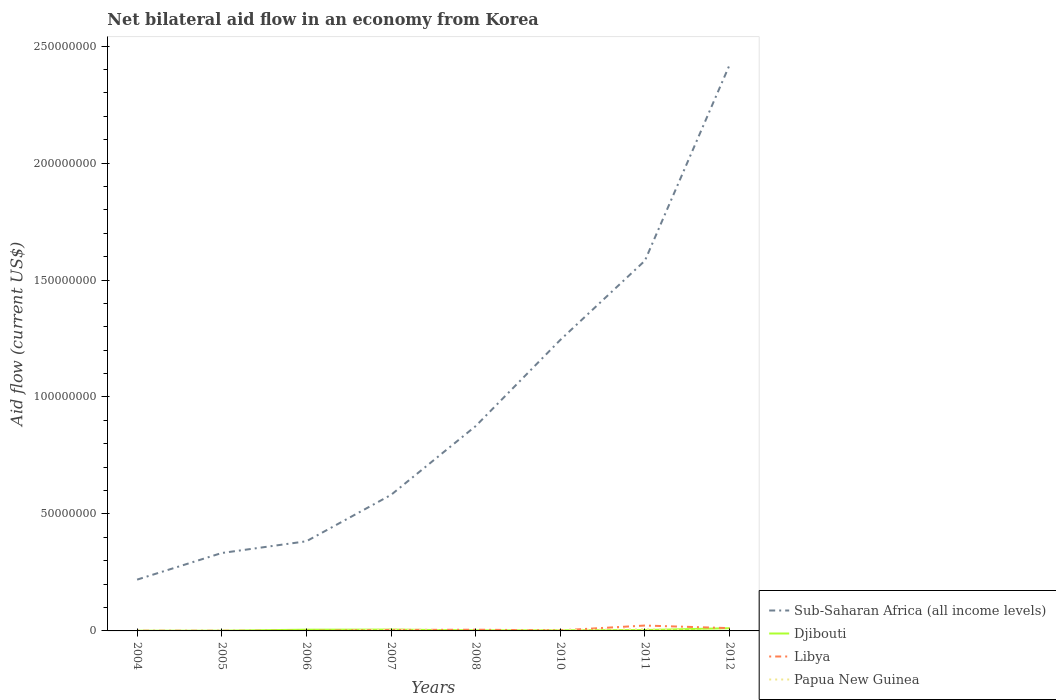Across all years, what is the maximum net bilateral aid flow in Libya?
Offer a terse response. 6.00e+04. What is the difference between the highest and the second highest net bilateral aid flow in Libya?
Provide a short and direct response. 2.24e+06. Is the net bilateral aid flow in Libya strictly greater than the net bilateral aid flow in Sub-Saharan Africa (all income levels) over the years?
Offer a terse response. Yes. How many lines are there?
Your response must be concise. 4. How many years are there in the graph?
Offer a very short reply. 8. Are the values on the major ticks of Y-axis written in scientific E-notation?
Ensure brevity in your answer.  No. How many legend labels are there?
Keep it short and to the point. 4. How are the legend labels stacked?
Make the answer very short. Vertical. What is the title of the graph?
Your answer should be very brief. Net bilateral aid flow in an economy from Korea. Does "Latin America(all income levels)" appear as one of the legend labels in the graph?
Your answer should be very brief. No. What is the label or title of the X-axis?
Make the answer very short. Years. What is the label or title of the Y-axis?
Offer a terse response. Aid flow (current US$). What is the Aid flow (current US$) of Sub-Saharan Africa (all income levels) in 2004?
Give a very brief answer. 2.19e+07. What is the Aid flow (current US$) of Libya in 2004?
Give a very brief answer. 9.00e+04. What is the Aid flow (current US$) in Papua New Guinea in 2004?
Make the answer very short. 0. What is the Aid flow (current US$) in Sub-Saharan Africa (all income levels) in 2005?
Ensure brevity in your answer.  3.33e+07. What is the Aid flow (current US$) of Djibouti in 2005?
Your answer should be compact. 1.00e+05. What is the Aid flow (current US$) of Papua New Guinea in 2005?
Keep it short and to the point. 0. What is the Aid flow (current US$) of Sub-Saharan Africa (all income levels) in 2006?
Your answer should be compact. 3.83e+07. What is the Aid flow (current US$) in Djibouti in 2006?
Provide a succinct answer. 5.30e+05. What is the Aid flow (current US$) in Libya in 2006?
Your answer should be compact. 6.00e+04. What is the Aid flow (current US$) of Sub-Saharan Africa (all income levels) in 2007?
Ensure brevity in your answer.  5.82e+07. What is the Aid flow (current US$) in Djibouti in 2007?
Give a very brief answer. 5.70e+05. What is the Aid flow (current US$) in Papua New Guinea in 2007?
Your response must be concise. 6.90e+05. What is the Aid flow (current US$) of Sub-Saharan Africa (all income levels) in 2008?
Keep it short and to the point. 8.76e+07. What is the Aid flow (current US$) in Libya in 2008?
Your response must be concise. 5.20e+05. What is the Aid flow (current US$) of Papua New Guinea in 2008?
Give a very brief answer. 0. What is the Aid flow (current US$) of Sub-Saharan Africa (all income levels) in 2010?
Offer a terse response. 1.24e+08. What is the Aid flow (current US$) in Djibouti in 2010?
Provide a succinct answer. 2.70e+05. What is the Aid flow (current US$) in Libya in 2010?
Offer a terse response. 2.40e+05. What is the Aid flow (current US$) in Papua New Guinea in 2010?
Give a very brief answer. 3.90e+05. What is the Aid flow (current US$) of Sub-Saharan Africa (all income levels) in 2011?
Give a very brief answer. 1.58e+08. What is the Aid flow (current US$) in Djibouti in 2011?
Keep it short and to the point. 3.90e+05. What is the Aid flow (current US$) in Libya in 2011?
Offer a terse response. 2.30e+06. What is the Aid flow (current US$) of Papua New Guinea in 2011?
Provide a short and direct response. 6.80e+05. What is the Aid flow (current US$) of Sub-Saharan Africa (all income levels) in 2012?
Provide a succinct answer. 2.42e+08. What is the Aid flow (current US$) in Djibouti in 2012?
Offer a very short reply. 1.16e+06. What is the Aid flow (current US$) in Libya in 2012?
Offer a terse response. 1.19e+06. What is the Aid flow (current US$) of Papua New Guinea in 2012?
Make the answer very short. 2.00e+04. Across all years, what is the maximum Aid flow (current US$) of Sub-Saharan Africa (all income levels)?
Your response must be concise. 2.42e+08. Across all years, what is the maximum Aid flow (current US$) of Djibouti?
Offer a very short reply. 1.16e+06. Across all years, what is the maximum Aid flow (current US$) in Libya?
Offer a terse response. 2.30e+06. Across all years, what is the maximum Aid flow (current US$) in Papua New Guinea?
Give a very brief answer. 6.90e+05. Across all years, what is the minimum Aid flow (current US$) in Sub-Saharan Africa (all income levels)?
Ensure brevity in your answer.  2.19e+07. Across all years, what is the minimum Aid flow (current US$) of Djibouti?
Ensure brevity in your answer.  9.00e+04. What is the total Aid flow (current US$) of Sub-Saharan Africa (all income levels) in the graph?
Your answer should be very brief. 7.64e+08. What is the total Aid flow (current US$) of Djibouti in the graph?
Offer a very short reply. 3.36e+06. What is the total Aid flow (current US$) in Libya in the graph?
Keep it short and to the point. 4.90e+06. What is the total Aid flow (current US$) in Papua New Guinea in the graph?
Your answer should be very brief. 1.78e+06. What is the difference between the Aid flow (current US$) in Sub-Saharan Africa (all income levels) in 2004 and that in 2005?
Your answer should be compact. -1.14e+07. What is the difference between the Aid flow (current US$) of Libya in 2004 and that in 2005?
Your response must be concise. 10000. What is the difference between the Aid flow (current US$) of Sub-Saharan Africa (all income levels) in 2004 and that in 2006?
Provide a short and direct response. -1.64e+07. What is the difference between the Aid flow (current US$) of Djibouti in 2004 and that in 2006?
Give a very brief answer. -4.40e+05. What is the difference between the Aid flow (current US$) in Libya in 2004 and that in 2006?
Your response must be concise. 3.00e+04. What is the difference between the Aid flow (current US$) of Sub-Saharan Africa (all income levels) in 2004 and that in 2007?
Your answer should be very brief. -3.62e+07. What is the difference between the Aid flow (current US$) of Djibouti in 2004 and that in 2007?
Provide a short and direct response. -4.80e+05. What is the difference between the Aid flow (current US$) of Libya in 2004 and that in 2007?
Your response must be concise. -3.30e+05. What is the difference between the Aid flow (current US$) in Sub-Saharan Africa (all income levels) in 2004 and that in 2008?
Make the answer very short. -6.56e+07. What is the difference between the Aid flow (current US$) of Libya in 2004 and that in 2008?
Give a very brief answer. -4.30e+05. What is the difference between the Aid flow (current US$) in Sub-Saharan Africa (all income levels) in 2004 and that in 2010?
Provide a succinct answer. -1.02e+08. What is the difference between the Aid flow (current US$) of Sub-Saharan Africa (all income levels) in 2004 and that in 2011?
Make the answer very short. -1.36e+08. What is the difference between the Aid flow (current US$) of Djibouti in 2004 and that in 2011?
Give a very brief answer. -3.00e+05. What is the difference between the Aid flow (current US$) of Libya in 2004 and that in 2011?
Your answer should be very brief. -2.21e+06. What is the difference between the Aid flow (current US$) of Sub-Saharan Africa (all income levels) in 2004 and that in 2012?
Offer a terse response. -2.20e+08. What is the difference between the Aid flow (current US$) in Djibouti in 2004 and that in 2012?
Keep it short and to the point. -1.07e+06. What is the difference between the Aid flow (current US$) in Libya in 2004 and that in 2012?
Your response must be concise. -1.10e+06. What is the difference between the Aid flow (current US$) of Sub-Saharan Africa (all income levels) in 2005 and that in 2006?
Offer a terse response. -5.01e+06. What is the difference between the Aid flow (current US$) of Djibouti in 2005 and that in 2006?
Offer a very short reply. -4.30e+05. What is the difference between the Aid flow (current US$) of Sub-Saharan Africa (all income levels) in 2005 and that in 2007?
Offer a very short reply. -2.48e+07. What is the difference between the Aid flow (current US$) of Djibouti in 2005 and that in 2007?
Your response must be concise. -4.70e+05. What is the difference between the Aid flow (current US$) of Sub-Saharan Africa (all income levels) in 2005 and that in 2008?
Keep it short and to the point. -5.42e+07. What is the difference between the Aid flow (current US$) in Libya in 2005 and that in 2008?
Your answer should be very brief. -4.40e+05. What is the difference between the Aid flow (current US$) in Sub-Saharan Africa (all income levels) in 2005 and that in 2010?
Your response must be concise. -9.11e+07. What is the difference between the Aid flow (current US$) of Sub-Saharan Africa (all income levels) in 2005 and that in 2011?
Your response must be concise. -1.25e+08. What is the difference between the Aid flow (current US$) of Djibouti in 2005 and that in 2011?
Ensure brevity in your answer.  -2.90e+05. What is the difference between the Aid flow (current US$) of Libya in 2005 and that in 2011?
Offer a terse response. -2.22e+06. What is the difference between the Aid flow (current US$) in Sub-Saharan Africa (all income levels) in 2005 and that in 2012?
Keep it short and to the point. -2.09e+08. What is the difference between the Aid flow (current US$) of Djibouti in 2005 and that in 2012?
Your answer should be compact. -1.06e+06. What is the difference between the Aid flow (current US$) of Libya in 2005 and that in 2012?
Your answer should be compact. -1.11e+06. What is the difference between the Aid flow (current US$) of Sub-Saharan Africa (all income levels) in 2006 and that in 2007?
Ensure brevity in your answer.  -1.98e+07. What is the difference between the Aid flow (current US$) of Libya in 2006 and that in 2007?
Give a very brief answer. -3.60e+05. What is the difference between the Aid flow (current US$) of Sub-Saharan Africa (all income levels) in 2006 and that in 2008?
Provide a succinct answer. -4.92e+07. What is the difference between the Aid flow (current US$) in Libya in 2006 and that in 2008?
Offer a very short reply. -4.60e+05. What is the difference between the Aid flow (current US$) in Sub-Saharan Africa (all income levels) in 2006 and that in 2010?
Provide a succinct answer. -8.61e+07. What is the difference between the Aid flow (current US$) of Djibouti in 2006 and that in 2010?
Offer a terse response. 2.60e+05. What is the difference between the Aid flow (current US$) in Sub-Saharan Africa (all income levels) in 2006 and that in 2011?
Provide a short and direct response. -1.20e+08. What is the difference between the Aid flow (current US$) of Libya in 2006 and that in 2011?
Provide a short and direct response. -2.24e+06. What is the difference between the Aid flow (current US$) in Sub-Saharan Africa (all income levels) in 2006 and that in 2012?
Your response must be concise. -2.04e+08. What is the difference between the Aid flow (current US$) of Djibouti in 2006 and that in 2012?
Give a very brief answer. -6.30e+05. What is the difference between the Aid flow (current US$) in Libya in 2006 and that in 2012?
Offer a terse response. -1.13e+06. What is the difference between the Aid flow (current US$) in Sub-Saharan Africa (all income levels) in 2007 and that in 2008?
Offer a very short reply. -2.94e+07. What is the difference between the Aid flow (current US$) in Libya in 2007 and that in 2008?
Your answer should be very brief. -1.00e+05. What is the difference between the Aid flow (current US$) in Sub-Saharan Africa (all income levels) in 2007 and that in 2010?
Offer a very short reply. -6.62e+07. What is the difference between the Aid flow (current US$) of Libya in 2007 and that in 2010?
Offer a very short reply. 1.80e+05. What is the difference between the Aid flow (current US$) of Papua New Guinea in 2007 and that in 2010?
Your response must be concise. 3.00e+05. What is the difference between the Aid flow (current US$) of Sub-Saharan Africa (all income levels) in 2007 and that in 2011?
Ensure brevity in your answer.  -1.00e+08. What is the difference between the Aid flow (current US$) in Djibouti in 2007 and that in 2011?
Offer a terse response. 1.80e+05. What is the difference between the Aid flow (current US$) in Libya in 2007 and that in 2011?
Make the answer very short. -1.88e+06. What is the difference between the Aid flow (current US$) of Sub-Saharan Africa (all income levels) in 2007 and that in 2012?
Your response must be concise. -1.84e+08. What is the difference between the Aid flow (current US$) in Djibouti in 2007 and that in 2012?
Make the answer very short. -5.90e+05. What is the difference between the Aid flow (current US$) in Libya in 2007 and that in 2012?
Give a very brief answer. -7.70e+05. What is the difference between the Aid flow (current US$) of Papua New Guinea in 2007 and that in 2012?
Provide a succinct answer. 6.70e+05. What is the difference between the Aid flow (current US$) in Sub-Saharan Africa (all income levels) in 2008 and that in 2010?
Your answer should be very brief. -3.68e+07. What is the difference between the Aid flow (current US$) in Djibouti in 2008 and that in 2010?
Offer a terse response. -2.00e+04. What is the difference between the Aid flow (current US$) in Sub-Saharan Africa (all income levels) in 2008 and that in 2011?
Give a very brief answer. -7.07e+07. What is the difference between the Aid flow (current US$) in Libya in 2008 and that in 2011?
Keep it short and to the point. -1.78e+06. What is the difference between the Aid flow (current US$) of Sub-Saharan Africa (all income levels) in 2008 and that in 2012?
Keep it short and to the point. -1.54e+08. What is the difference between the Aid flow (current US$) of Djibouti in 2008 and that in 2012?
Your answer should be compact. -9.10e+05. What is the difference between the Aid flow (current US$) of Libya in 2008 and that in 2012?
Give a very brief answer. -6.70e+05. What is the difference between the Aid flow (current US$) in Sub-Saharan Africa (all income levels) in 2010 and that in 2011?
Offer a terse response. -3.39e+07. What is the difference between the Aid flow (current US$) of Libya in 2010 and that in 2011?
Offer a terse response. -2.06e+06. What is the difference between the Aid flow (current US$) in Papua New Guinea in 2010 and that in 2011?
Your answer should be compact. -2.90e+05. What is the difference between the Aid flow (current US$) in Sub-Saharan Africa (all income levels) in 2010 and that in 2012?
Offer a terse response. -1.18e+08. What is the difference between the Aid flow (current US$) in Djibouti in 2010 and that in 2012?
Provide a succinct answer. -8.90e+05. What is the difference between the Aid flow (current US$) of Libya in 2010 and that in 2012?
Provide a short and direct response. -9.50e+05. What is the difference between the Aid flow (current US$) in Papua New Guinea in 2010 and that in 2012?
Provide a short and direct response. 3.70e+05. What is the difference between the Aid flow (current US$) in Sub-Saharan Africa (all income levels) in 2011 and that in 2012?
Offer a terse response. -8.37e+07. What is the difference between the Aid flow (current US$) of Djibouti in 2011 and that in 2012?
Offer a terse response. -7.70e+05. What is the difference between the Aid flow (current US$) in Libya in 2011 and that in 2012?
Provide a succinct answer. 1.11e+06. What is the difference between the Aid flow (current US$) in Sub-Saharan Africa (all income levels) in 2004 and the Aid flow (current US$) in Djibouti in 2005?
Your answer should be very brief. 2.18e+07. What is the difference between the Aid flow (current US$) in Sub-Saharan Africa (all income levels) in 2004 and the Aid flow (current US$) in Libya in 2005?
Your answer should be compact. 2.18e+07. What is the difference between the Aid flow (current US$) of Djibouti in 2004 and the Aid flow (current US$) of Libya in 2005?
Ensure brevity in your answer.  10000. What is the difference between the Aid flow (current US$) in Sub-Saharan Africa (all income levels) in 2004 and the Aid flow (current US$) in Djibouti in 2006?
Your answer should be compact. 2.14e+07. What is the difference between the Aid flow (current US$) in Sub-Saharan Africa (all income levels) in 2004 and the Aid flow (current US$) in Libya in 2006?
Offer a very short reply. 2.19e+07. What is the difference between the Aid flow (current US$) in Djibouti in 2004 and the Aid flow (current US$) in Libya in 2006?
Your response must be concise. 3.00e+04. What is the difference between the Aid flow (current US$) in Sub-Saharan Africa (all income levels) in 2004 and the Aid flow (current US$) in Djibouti in 2007?
Ensure brevity in your answer.  2.14e+07. What is the difference between the Aid flow (current US$) in Sub-Saharan Africa (all income levels) in 2004 and the Aid flow (current US$) in Libya in 2007?
Offer a very short reply. 2.15e+07. What is the difference between the Aid flow (current US$) of Sub-Saharan Africa (all income levels) in 2004 and the Aid flow (current US$) of Papua New Guinea in 2007?
Give a very brief answer. 2.12e+07. What is the difference between the Aid flow (current US$) of Djibouti in 2004 and the Aid flow (current US$) of Libya in 2007?
Your answer should be compact. -3.30e+05. What is the difference between the Aid flow (current US$) in Djibouti in 2004 and the Aid flow (current US$) in Papua New Guinea in 2007?
Make the answer very short. -6.00e+05. What is the difference between the Aid flow (current US$) of Libya in 2004 and the Aid flow (current US$) of Papua New Guinea in 2007?
Your answer should be compact. -6.00e+05. What is the difference between the Aid flow (current US$) in Sub-Saharan Africa (all income levels) in 2004 and the Aid flow (current US$) in Djibouti in 2008?
Make the answer very short. 2.17e+07. What is the difference between the Aid flow (current US$) in Sub-Saharan Africa (all income levels) in 2004 and the Aid flow (current US$) in Libya in 2008?
Provide a short and direct response. 2.14e+07. What is the difference between the Aid flow (current US$) in Djibouti in 2004 and the Aid flow (current US$) in Libya in 2008?
Your answer should be compact. -4.30e+05. What is the difference between the Aid flow (current US$) in Sub-Saharan Africa (all income levels) in 2004 and the Aid flow (current US$) in Djibouti in 2010?
Provide a succinct answer. 2.17e+07. What is the difference between the Aid flow (current US$) of Sub-Saharan Africa (all income levels) in 2004 and the Aid flow (current US$) of Libya in 2010?
Offer a very short reply. 2.17e+07. What is the difference between the Aid flow (current US$) of Sub-Saharan Africa (all income levels) in 2004 and the Aid flow (current US$) of Papua New Guinea in 2010?
Give a very brief answer. 2.15e+07. What is the difference between the Aid flow (current US$) of Djibouti in 2004 and the Aid flow (current US$) of Papua New Guinea in 2010?
Offer a terse response. -3.00e+05. What is the difference between the Aid flow (current US$) of Libya in 2004 and the Aid flow (current US$) of Papua New Guinea in 2010?
Offer a terse response. -3.00e+05. What is the difference between the Aid flow (current US$) of Sub-Saharan Africa (all income levels) in 2004 and the Aid flow (current US$) of Djibouti in 2011?
Give a very brief answer. 2.15e+07. What is the difference between the Aid flow (current US$) in Sub-Saharan Africa (all income levels) in 2004 and the Aid flow (current US$) in Libya in 2011?
Keep it short and to the point. 1.96e+07. What is the difference between the Aid flow (current US$) in Sub-Saharan Africa (all income levels) in 2004 and the Aid flow (current US$) in Papua New Guinea in 2011?
Provide a short and direct response. 2.12e+07. What is the difference between the Aid flow (current US$) of Djibouti in 2004 and the Aid flow (current US$) of Libya in 2011?
Give a very brief answer. -2.21e+06. What is the difference between the Aid flow (current US$) in Djibouti in 2004 and the Aid flow (current US$) in Papua New Guinea in 2011?
Give a very brief answer. -5.90e+05. What is the difference between the Aid flow (current US$) in Libya in 2004 and the Aid flow (current US$) in Papua New Guinea in 2011?
Provide a short and direct response. -5.90e+05. What is the difference between the Aid flow (current US$) of Sub-Saharan Africa (all income levels) in 2004 and the Aid flow (current US$) of Djibouti in 2012?
Offer a very short reply. 2.08e+07. What is the difference between the Aid flow (current US$) of Sub-Saharan Africa (all income levels) in 2004 and the Aid flow (current US$) of Libya in 2012?
Offer a very short reply. 2.07e+07. What is the difference between the Aid flow (current US$) of Sub-Saharan Africa (all income levels) in 2004 and the Aid flow (current US$) of Papua New Guinea in 2012?
Make the answer very short. 2.19e+07. What is the difference between the Aid flow (current US$) in Djibouti in 2004 and the Aid flow (current US$) in Libya in 2012?
Offer a terse response. -1.10e+06. What is the difference between the Aid flow (current US$) in Djibouti in 2004 and the Aid flow (current US$) in Papua New Guinea in 2012?
Your response must be concise. 7.00e+04. What is the difference between the Aid flow (current US$) of Sub-Saharan Africa (all income levels) in 2005 and the Aid flow (current US$) of Djibouti in 2006?
Your answer should be very brief. 3.28e+07. What is the difference between the Aid flow (current US$) of Sub-Saharan Africa (all income levels) in 2005 and the Aid flow (current US$) of Libya in 2006?
Your response must be concise. 3.32e+07. What is the difference between the Aid flow (current US$) in Sub-Saharan Africa (all income levels) in 2005 and the Aid flow (current US$) in Djibouti in 2007?
Keep it short and to the point. 3.27e+07. What is the difference between the Aid flow (current US$) of Sub-Saharan Africa (all income levels) in 2005 and the Aid flow (current US$) of Libya in 2007?
Ensure brevity in your answer.  3.29e+07. What is the difference between the Aid flow (current US$) of Sub-Saharan Africa (all income levels) in 2005 and the Aid flow (current US$) of Papua New Guinea in 2007?
Your answer should be very brief. 3.26e+07. What is the difference between the Aid flow (current US$) of Djibouti in 2005 and the Aid flow (current US$) of Libya in 2007?
Keep it short and to the point. -3.20e+05. What is the difference between the Aid flow (current US$) of Djibouti in 2005 and the Aid flow (current US$) of Papua New Guinea in 2007?
Provide a succinct answer. -5.90e+05. What is the difference between the Aid flow (current US$) of Libya in 2005 and the Aid flow (current US$) of Papua New Guinea in 2007?
Provide a short and direct response. -6.10e+05. What is the difference between the Aid flow (current US$) in Sub-Saharan Africa (all income levels) in 2005 and the Aid flow (current US$) in Djibouti in 2008?
Make the answer very short. 3.31e+07. What is the difference between the Aid flow (current US$) of Sub-Saharan Africa (all income levels) in 2005 and the Aid flow (current US$) of Libya in 2008?
Ensure brevity in your answer.  3.28e+07. What is the difference between the Aid flow (current US$) of Djibouti in 2005 and the Aid flow (current US$) of Libya in 2008?
Provide a short and direct response. -4.20e+05. What is the difference between the Aid flow (current US$) in Sub-Saharan Africa (all income levels) in 2005 and the Aid flow (current US$) in Djibouti in 2010?
Your answer should be very brief. 3.30e+07. What is the difference between the Aid flow (current US$) in Sub-Saharan Africa (all income levels) in 2005 and the Aid flow (current US$) in Libya in 2010?
Keep it short and to the point. 3.31e+07. What is the difference between the Aid flow (current US$) of Sub-Saharan Africa (all income levels) in 2005 and the Aid flow (current US$) of Papua New Guinea in 2010?
Make the answer very short. 3.29e+07. What is the difference between the Aid flow (current US$) of Libya in 2005 and the Aid flow (current US$) of Papua New Guinea in 2010?
Ensure brevity in your answer.  -3.10e+05. What is the difference between the Aid flow (current US$) of Sub-Saharan Africa (all income levels) in 2005 and the Aid flow (current US$) of Djibouti in 2011?
Provide a short and direct response. 3.29e+07. What is the difference between the Aid flow (current US$) in Sub-Saharan Africa (all income levels) in 2005 and the Aid flow (current US$) in Libya in 2011?
Give a very brief answer. 3.10e+07. What is the difference between the Aid flow (current US$) in Sub-Saharan Africa (all income levels) in 2005 and the Aid flow (current US$) in Papua New Guinea in 2011?
Offer a terse response. 3.26e+07. What is the difference between the Aid flow (current US$) in Djibouti in 2005 and the Aid flow (current US$) in Libya in 2011?
Give a very brief answer. -2.20e+06. What is the difference between the Aid flow (current US$) in Djibouti in 2005 and the Aid flow (current US$) in Papua New Guinea in 2011?
Provide a succinct answer. -5.80e+05. What is the difference between the Aid flow (current US$) of Libya in 2005 and the Aid flow (current US$) of Papua New Guinea in 2011?
Offer a very short reply. -6.00e+05. What is the difference between the Aid flow (current US$) in Sub-Saharan Africa (all income levels) in 2005 and the Aid flow (current US$) in Djibouti in 2012?
Provide a succinct answer. 3.22e+07. What is the difference between the Aid flow (current US$) in Sub-Saharan Africa (all income levels) in 2005 and the Aid flow (current US$) in Libya in 2012?
Keep it short and to the point. 3.21e+07. What is the difference between the Aid flow (current US$) in Sub-Saharan Africa (all income levels) in 2005 and the Aid flow (current US$) in Papua New Guinea in 2012?
Offer a very short reply. 3.33e+07. What is the difference between the Aid flow (current US$) of Djibouti in 2005 and the Aid flow (current US$) of Libya in 2012?
Offer a very short reply. -1.09e+06. What is the difference between the Aid flow (current US$) in Sub-Saharan Africa (all income levels) in 2006 and the Aid flow (current US$) in Djibouti in 2007?
Ensure brevity in your answer.  3.78e+07. What is the difference between the Aid flow (current US$) in Sub-Saharan Africa (all income levels) in 2006 and the Aid flow (current US$) in Libya in 2007?
Make the answer very short. 3.79e+07. What is the difference between the Aid flow (current US$) in Sub-Saharan Africa (all income levels) in 2006 and the Aid flow (current US$) in Papua New Guinea in 2007?
Make the answer very short. 3.76e+07. What is the difference between the Aid flow (current US$) in Djibouti in 2006 and the Aid flow (current US$) in Libya in 2007?
Your response must be concise. 1.10e+05. What is the difference between the Aid flow (current US$) in Djibouti in 2006 and the Aid flow (current US$) in Papua New Guinea in 2007?
Your answer should be compact. -1.60e+05. What is the difference between the Aid flow (current US$) of Libya in 2006 and the Aid flow (current US$) of Papua New Guinea in 2007?
Offer a very short reply. -6.30e+05. What is the difference between the Aid flow (current US$) in Sub-Saharan Africa (all income levels) in 2006 and the Aid flow (current US$) in Djibouti in 2008?
Offer a terse response. 3.81e+07. What is the difference between the Aid flow (current US$) in Sub-Saharan Africa (all income levels) in 2006 and the Aid flow (current US$) in Libya in 2008?
Provide a short and direct response. 3.78e+07. What is the difference between the Aid flow (current US$) in Djibouti in 2006 and the Aid flow (current US$) in Libya in 2008?
Your answer should be very brief. 10000. What is the difference between the Aid flow (current US$) of Sub-Saharan Africa (all income levels) in 2006 and the Aid flow (current US$) of Djibouti in 2010?
Provide a short and direct response. 3.80e+07. What is the difference between the Aid flow (current US$) in Sub-Saharan Africa (all income levels) in 2006 and the Aid flow (current US$) in Libya in 2010?
Your answer should be compact. 3.81e+07. What is the difference between the Aid flow (current US$) in Sub-Saharan Africa (all income levels) in 2006 and the Aid flow (current US$) in Papua New Guinea in 2010?
Offer a very short reply. 3.79e+07. What is the difference between the Aid flow (current US$) of Djibouti in 2006 and the Aid flow (current US$) of Papua New Guinea in 2010?
Your answer should be compact. 1.40e+05. What is the difference between the Aid flow (current US$) of Libya in 2006 and the Aid flow (current US$) of Papua New Guinea in 2010?
Ensure brevity in your answer.  -3.30e+05. What is the difference between the Aid flow (current US$) in Sub-Saharan Africa (all income levels) in 2006 and the Aid flow (current US$) in Djibouti in 2011?
Offer a terse response. 3.79e+07. What is the difference between the Aid flow (current US$) of Sub-Saharan Africa (all income levels) in 2006 and the Aid flow (current US$) of Libya in 2011?
Offer a very short reply. 3.60e+07. What is the difference between the Aid flow (current US$) of Sub-Saharan Africa (all income levels) in 2006 and the Aid flow (current US$) of Papua New Guinea in 2011?
Your answer should be very brief. 3.76e+07. What is the difference between the Aid flow (current US$) of Djibouti in 2006 and the Aid flow (current US$) of Libya in 2011?
Offer a terse response. -1.77e+06. What is the difference between the Aid flow (current US$) of Djibouti in 2006 and the Aid flow (current US$) of Papua New Guinea in 2011?
Keep it short and to the point. -1.50e+05. What is the difference between the Aid flow (current US$) of Libya in 2006 and the Aid flow (current US$) of Papua New Guinea in 2011?
Give a very brief answer. -6.20e+05. What is the difference between the Aid flow (current US$) of Sub-Saharan Africa (all income levels) in 2006 and the Aid flow (current US$) of Djibouti in 2012?
Ensure brevity in your answer.  3.72e+07. What is the difference between the Aid flow (current US$) in Sub-Saharan Africa (all income levels) in 2006 and the Aid flow (current US$) in Libya in 2012?
Your response must be concise. 3.71e+07. What is the difference between the Aid flow (current US$) of Sub-Saharan Africa (all income levels) in 2006 and the Aid flow (current US$) of Papua New Guinea in 2012?
Keep it short and to the point. 3.83e+07. What is the difference between the Aid flow (current US$) of Djibouti in 2006 and the Aid flow (current US$) of Libya in 2012?
Offer a terse response. -6.60e+05. What is the difference between the Aid flow (current US$) in Djibouti in 2006 and the Aid flow (current US$) in Papua New Guinea in 2012?
Your answer should be compact. 5.10e+05. What is the difference between the Aid flow (current US$) of Sub-Saharan Africa (all income levels) in 2007 and the Aid flow (current US$) of Djibouti in 2008?
Offer a terse response. 5.79e+07. What is the difference between the Aid flow (current US$) in Sub-Saharan Africa (all income levels) in 2007 and the Aid flow (current US$) in Libya in 2008?
Your response must be concise. 5.76e+07. What is the difference between the Aid flow (current US$) in Djibouti in 2007 and the Aid flow (current US$) in Libya in 2008?
Provide a short and direct response. 5.00e+04. What is the difference between the Aid flow (current US$) in Sub-Saharan Africa (all income levels) in 2007 and the Aid flow (current US$) in Djibouti in 2010?
Offer a terse response. 5.79e+07. What is the difference between the Aid flow (current US$) in Sub-Saharan Africa (all income levels) in 2007 and the Aid flow (current US$) in Libya in 2010?
Make the answer very short. 5.79e+07. What is the difference between the Aid flow (current US$) of Sub-Saharan Africa (all income levels) in 2007 and the Aid flow (current US$) of Papua New Guinea in 2010?
Offer a very short reply. 5.78e+07. What is the difference between the Aid flow (current US$) of Djibouti in 2007 and the Aid flow (current US$) of Libya in 2010?
Give a very brief answer. 3.30e+05. What is the difference between the Aid flow (current US$) of Djibouti in 2007 and the Aid flow (current US$) of Papua New Guinea in 2010?
Offer a very short reply. 1.80e+05. What is the difference between the Aid flow (current US$) in Sub-Saharan Africa (all income levels) in 2007 and the Aid flow (current US$) in Djibouti in 2011?
Your answer should be very brief. 5.78e+07. What is the difference between the Aid flow (current US$) of Sub-Saharan Africa (all income levels) in 2007 and the Aid flow (current US$) of Libya in 2011?
Provide a short and direct response. 5.58e+07. What is the difference between the Aid flow (current US$) of Sub-Saharan Africa (all income levels) in 2007 and the Aid flow (current US$) of Papua New Guinea in 2011?
Provide a short and direct response. 5.75e+07. What is the difference between the Aid flow (current US$) in Djibouti in 2007 and the Aid flow (current US$) in Libya in 2011?
Your answer should be very brief. -1.73e+06. What is the difference between the Aid flow (current US$) of Sub-Saharan Africa (all income levels) in 2007 and the Aid flow (current US$) of Djibouti in 2012?
Ensure brevity in your answer.  5.70e+07. What is the difference between the Aid flow (current US$) of Sub-Saharan Africa (all income levels) in 2007 and the Aid flow (current US$) of Libya in 2012?
Make the answer very short. 5.70e+07. What is the difference between the Aid flow (current US$) in Sub-Saharan Africa (all income levels) in 2007 and the Aid flow (current US$) in Papua New Guinea in 2012?
Your answer should be very brief. 5.81e+07. What is the difference between the Aid flow (current US$) of Djibouti in 2007 and the Aid flow (current US$) of Libya in 2012?
Provide a succinct answer. -6.20e+05. What is the difference between the Aid flow (current US$) of Djibouti in 2007 and the Aid flow (current US$) of Papua New Guinea in 2012?
Your answer should be compact. 5.50e+05. What is the difference between the Aid flow (current US$) in Sub-Saharan Africa (all income levels) in 2008 and the Aid flow (current US$) in Djibouti in 2010?
Your response must be concise. 8.73e+07. What is the difference between the Aid flow (current US$) of Sub-Saharan Africa (all income levels) in 2008 and the Aid flow (current US$) of Libya in 2010?
Keep it short and to the point. 8.73e+07. What is the difference between the Aid flow (current US$) in Sub-Saharan Africa (all income levels) in 2008 and the Aid flow (current US$) in Papua New Guinea in 2010?
Offer a terse response. 8.72e+07. What is the difference between the Aid flow (current US$) in Djibouti in 2008 and the Aid flow (current US$) in Libya in 2010?
Your answer should be very brief. 10000. What is the difference between the Aid flow (current US$) of Sub-Saharan Africa (all income levels) in 2008 and the Aid flow (current US$) of Djibouti in 2011?
Make the answer very short. 8.72e+07. What is the difference between the Aid flow (current US$) in Sub-Saharan Africa (all income levels) in 2008 and the Aid flow (current US$) in Libya in 2011?
Your answer should be compact. 8.52e+07. What is the difference between the Aid flow (current US$) of Sub-Saharan Africa (all income levels) in 2008 and the Aid flow (current US$) of Papua New Guinea in 2011?
Provide a short and direct response. 8.69e+07. What is the difference between the Aid flow (current US$) in Djibouti in 2008 and the Aid flow (current US$) in Libya in 2011?
Your answer should be very brief. -2.05e+06. What is the difference between the Aid flow (current US$) of Djibouti in 2008 and the Aid flow (current US$) of Papua New Guinea in 2011?
Your answer should be very brief. -4.30e+05. What is the difference between the Aid flow (current US$) in Sub-Saharan Africa (all income levels) in 2008 and the Aid flow (current US$) in Djibouti in 2012?
Provide a succinct answer. 8.64e+07. What is the difference between the Aid flow (current US$) of Sub-Saharan Africa (all income levels) in 2008 and the Aid flow (current US$) of Libya in 2012?
Give a very brief answer. 8.64e+07. What is the difference between the Aid flow (current US$) in Sub-Saharan Africa (all income levels) in 2008 and the Aid flow (current US$) in Papua New Guinea in 2012?
Provide a succinct answer. 8.75e+07. What is the difference between the Aid flow (current US$) of Djibouti in 2008 and the Aid flow (current US$) of Libya in 2012?
Ensure brevity in your answer.  -9.40e+05. What is the difference between the Aid flow (current US$) in Djibouti in 2008 and the Aid flow (current US$) in Papua New Guinea in 2012?
Ensure brevity in your answer.  2.30e+05. What is the difference between the Aid flow (current US$) in Libya in 2008 and the Aid flow (current US$) in Papua New Guinea in 2012?
Offer a very short reply. 5.00e+05. What is the difference between the Aid flow (current US$) of Sub-Saharan Africa (all income levels) in 2010 and the Aid flow (current US$) of Djibouti in 2011?
Provide a succinct answer. 1.24e+08. What is the difference between the Aid flow (current US$) of Sub-Saharan Africa (all income levels) in 2010 and the Aid flow (current US$) of Libya in 2011?
Make the answer very short. 1.22e+08. What is the difference between the Aid flow (current US$) in Sub-Saharan Africa (all income levels) in 2010 and the Aid flow (current US$) in Papua New Guinea in 2011?
Give a very brief answer. 1.24e+08. What is the difference between the Aid flow (current US$) of Djibouti in 2010 and the Aid flow (current US$) of Libya in 2011?
Keep it short and to the point. -2.03e+06. What is the difference between the Aid flow (current US$) in Djibouti in 2010 and the Aid flow (current US$) in Papua New Guinea in 2011?
Provide a short and direct response. -4.10e+05. What is the difference between the Aid flow (current US$) in Libya in 2010 and the Aid flow (current US$) in Papua New Guinea in 2011?
Your answer should be compact. -4.40e+05. What is the difference between the Aid flow (current US$) of Sub-Saharan Africa (all income levels) in 2010 and the Aid flow (current US$) of Djibouti in 2012?
Keep it short and to the point. 1.23e+08. What is the difference between the Aid flow (current US$) of Sub-Saharan Africa (all income levels) in 2010 and the Aid flow (current US$) of Libya in 2012?
Keep it short and to the point. 1.23e+08. What is the difference between the Aid flow (current US$) of Sub-Saharan Africa (all income levels) in 2010 and the Aid flow (current US$) of Papua New Guinea in 2012?
Give a very brief answer. 1.24e+08. What is the difference between the Aid flow (current US$) in Djibouti in 2010 and the Aid flow (current US$) in Libya in 2012?
Offer a very short reply. -9.20e+05. What is the difference between the Aid flow (current US$) of Sub-Saharan Africa (all income levels) in 2011 and the Aid flow (current US$) of Djibouti in 2012?
Give a very brief answer. 1.57e+08. What is the difference between the Aid flow (current US$) of Sub-Saharan Africa (all income levels) in 2011 and the Aid flow (current US$) of Libya in 2012?
Offer a terse response. 1.57e+08. What is the difference between the Aid flow (current US$) of Sub-Saharan Africa (all income levels) in 2011 and the Aid flow (current US$) of Papua New Guinea in 2012?
Make the answer very short. 1.58e+08. What is the difference between the Aid flow (current US$) in Djibouti in 2011 and the Aid flow (current US$) in Libya in 2012?
Provide a succinct answer. -8.00e+05. What is the difference between the Aid flow (current US$) of Djibouti in 2011 and the Aid flow (current US$) of Papua New Guinea in 2012?
Offer a terse response. 3.70e+05. What is the difference between the Aid flow (current US$) in Libya in 2011 and the Aid flow (current US$) in Papua New Guinea in 2012?
Your answer should be very brief. 2.28e+06. What is the average Aid flow (current US$) in Sub-Saharan Africa (all income levels) per year?
Provide a succinct answer. 9.55e+07. What is the average Aid flow (current US$) in Libya per year?
Keep it short and to the point. 6.12e+05. What is the average Aid flow (current US$) in Papua New Guinea per year?
Offer a terse response. 2.22e+05. In the year 2004, what is the difference between the Aid flow (current US$) of Sub-Saharan Africa (all income levels) and Aid flow (current US$) of Djibouti?
Keep it short and to the point. 2.18e+07. In the year 2004, what is the difference between the Aid flow (current US$) in Sub-Saharan Africa (all income levels) and Aid flow (current US$) in Libya?
Offer a terse response. 2.18e+07. In the year 2004, what is the difference between the Aid flow (current US$) in Djibouti and Aid flow (current US$) in Libya?
Your answer should be very brief. 0. In the year 2005, what is the difference between the Aid flow (current US$) of Sub-Saharan Africa (all income levels) and Aid flow (current US$) of Djibouti?
Your answer should be very brief. 3.32e+07. In the year 2005, what is the difference between the Aid flow (current US$) of Sub-Saharan Africa (all income levels) and Aid flow (current US$) of Libya?
Give a very brief answer. 3.32e+07. In the year 2005, what is the difference between the Aid flow (current US$) of Djibouti and Aid flow (current US$) of Libya?
Make the answer very short. 2.00e+04. In the year 2006, what is the difference between the Aid flow (current US$) of Sub-Saharan Africa (all income levels) and Aid flow (current US$) of Djibouti?
Keep it short and to the point. 3.78e+07. In the year 2006, what is the difference between the Aid flow (current US$) of Sub-Saharan Africa (all income levels) and Aid flow (current US$) of Libya?
Ensure brevity in your answer.  3.83e+07. In the year 2006, what is the difference between the Aid flow (current US$) of Djibouti and Aid flow (current US$) of Libya?
Make the answer very short. 4.70e+05. In the year 2007, what is the difference between the Aid flow (current US$) in Sub-Saharan Africa (all income levels) and Aid flow (current US$) in Djibouti?
Make the answer very short. 5.76e+07. In the year 2007, what is the difference between the Aid flow (current US$) of Sub-Saharan Africa (all income levels) and Aid flow (current US$) of Libya?
Ensure brevity in your answer.  5.77e+07. In the year 2007, what is the difference between the Aid flow (current US$) of Sub-Saharan Africa (all income levels) and Aid flow (current US$) of Papua New Guinea?
Ensure brevity in your answer.  5.75e+07. In the year 2007, what is the difference between the Aid flow (current US$) in Djibouti and Aid flow (current US$) in Papua New Guinea?
Offer a very short reply. -1.20e+05. In the year 2007, what is the difference between the Aid flow (current US$) of Libya and Aid flow (current US$) of Papua New Guinea?
Offer a terse response. -2.70e+05. In the year 2008, what is the difference between the Aid flow (current US$) in Sub-Saharan Africa (all income levels) and Aid flow (current US$) in Djibouti?
Offer a terse response. 8.73e+07. In the year 2008, what is the difference between the Aid flow (current US$) of Sub-Saharan Africa (all income levels) and Aid flow (current US$) of Libya?
Ensure brevity in your answer.  8.70e+07. In the year 2008, what is the difference between the Aid flow (current US$) of Djibouti and Aid flow (current US$) of Libya?
Keep it short and to the point. -2.70e+05. In the year 2010, what is the difference between the Aid flow (current US$) in Sub-Saharan Africa (all income levels) and Aid flow (current US$) in Djibouti?
Offer a very short reply. 1.24e+08. In the year 2010, what is the difference between the Aid flow (current US$) of Sub-Saharan Africa (all income levels) and Aid flow (current US$) of Libya?
Your answer should be very brief. 1.24e+08. In the year 2010, what is the difference between the Aid flow (current US$) in Sub-Saharan Africa (all income levels) and Aid flow (current US$) in Papua New Guinea?
Your response must be concise. 1.24e+08. In the year 2010, what is the difference between the Aid flow (current US$) of Djibouti and Aid flow (current US$) of Papua New Guinea?
Ensure brevity in your answer.  -1.20e+05. In the year 2011, what is the difference between the Aid flow (current US$) in Sub-Saharan Africa (all income levels) and Aid flow (current US$) in Djibouti?
Keep it short and to the point. 1.58e+08. In the year 2011, what is the difference between the Aid flow (current US$) of Sub-Saharan Africa (all income levels) and Aid flow (current US$) of Libya?
Ensure brevity in your answer.  1.56e+08. In the year 2011, what is the difference between the Aid flow (current US$) in Sub-Saharan Africa (all income levels) and Aid flow (current US$) in Papua New Guinea?
Your answer should be compact. 1.58e+08. In the year 2011, what is the difference between the Aid flow (current US$) in Djibouti and Aid flow (current US$) in Libya?
Give a very brief answer. -1.91e+06. In the year 2011, what is the difference between the Aid flow (current US$) of Djibouti and Aid flow (current US$) of Papua New Guinea?
Ensure brevity in your answer.  -2.90e+05. In the year 2011, what is the difference between the Aid flow (current US$) in Libya and Aid flow (current US$) in Papua New Guinea?
Provide a short and direct response. 1.62e+06. In the year 2012, what is the difference between the Aid flow (current US$) of Sub-Saharan Africa (all income levels) and Aid flow (current US$) of Djibouti?
Provide a succinct answer. 2.41e+08. In the year 2012, what is the difference between the Aid flow (current US$) in Sub-Saharan Africa (all income levels) and Aid flow (current US$) in Libya?
Offer a terse response. 2.41e+08. In the year 2012, what is the difference between the Aid flow (current US$) in Sub-Saharan Africa (all income levels) and Aid flow (current US$) in Papua New Guinea?
Provide a succinct answer. 2.42e+08. In the year 2012, what is the difference between the Aid flow (current US$) in Djibouti and Aid flow (current US$) in Papua New Guinea?
Give a very brief answer. 1.14e+06. In the year 2012, what is the difference between the Aid flow (current US$) of Libya and Aid flow (current US$) of Papua New Guinea?
Offer a terse response. 1.17e+06. What is the ratio of the Aid flow (current US$) of Sub-Saharan Africa (all income levels) in 2004 to that in 2005?
Offer a terse response. 0.66. What is the ratio of the Aid flow (current US$) in Djibouti in 2004 to that in 2005?
Provide a short and direct response. 0.9. What is the ratio of the Aid flow (current US$) in Libya in 2004 to that in 2005?
Give a very brief answer. 1.12. What is the ratio of the Aid flow (current US$) of Sub-Saharan Africa (all income levels) in 2004 to that in 2006?
Your answer should be compact. 0.57. What is the ratio of the Aid flow (current US$) in Djibouti in 2004 to that in 2006?
Provide a short and direct response. 0.17. What is the ratio of the Aid flow (current US$) in Libya in 2004 to that in 2006?
Your response must be concise. 1.5. What is the ratio of the Aid flow (current US$) in Sub-Saharan Africa (all income levels) in 2004 to that in 2007?
Your answer should be compact. 0.38. What is the ratio of the Aid flow (current US$) in Djibouti in 2004 to that in 2007?
Make the answer very short. 0.16. What is the ratio of the Aid flow (current US$) of Libya in 2004 to that in 2007?
Make the answer very short. 0.21. What is the ratio of the Aid flow (current US$) of Sub-Saharan Africa (all income levels) in 2004 to that in 2008?
Provide a short and direct response. 0.25. What is the ratio of the Aid flow (current US$) of Djibouti in 2004 to that in 2008?
Provide a succinct answer. 0.36. What is the ratio of the Aid flow (current US$) in Libya in 2004 to that in 2008?
Give a very brief answer. 0.17. What is the ratio of the Aid flow (current US$) in Sub-Saharan Africa (all income levels) in 2004 to that in 2010?
Ensure brevity in your answer.  0.18. What is the ratio of the Aid flow (current US$) of Djibouti in 2004 to that in 2010?
Provide a short and direct response. 0.33. What is the ratio of the Aid flow (current US$) in Sub-Saharan Africa (all income levels) in 2004 to that in 2011?
Give a very brief answer. 0.14. What is the ratio of the Aid flow (current US$) in Djibouti in 2004 to that in 2011?
Offer a very short reply. 0.23. What is the ratio of the Aid flow (current US$) of Libya in 2004 to that in 2011?
Give a very brief answer. 0.04. What is the ratio of the Aid flow (current US$) in Sub-Saharan Africa (all income levels) in 2004 to that in 2012?
Give a very brief answer. 0.09. What is the ratio of the Aid flow (current US$) in Djibouti in 2004 to that in 2012?
Your response must be concise. 0.08. What is the ratio of the Aid flow (current US$) in Libya in 2004 to that in 2012?
Offer a terse response. 0.08. What is the ratio of the Aid flow (current US$) of Sub-Saharan Africa (all income levels) in 2005 to that in 2006?
Your answer should be very brief. 0.87. What is the ratio of the Aid flow (current US$) of Djibouti in 2005 to that in 2006?
Make the answer very short. 0.19. What is the ratio of the Aid flow (current US$) of Sub-Saharan Africa (all income levels) in 2005 to that in 2007?
Your answer should be compact. 0.57. What is the ratio of the Aid flow (current US$) of Djibouti in 2005 to that in 2007?
Your answer should be very brief. 0.18. What is the ratio of the Aid flow (current US$) of Libya in 2005 to that in 2007?
Provide a short and direct response. 0.19. What is the ratio of the Aid flow (current US$) in Sub-Saharan Africa (all income levels) in 2005 to that in 2008?
Offer a very short reply. 0.38. What is the ratio of the Aid flow (current US$) of Libya in 2005 to that in 2008?
Keep it short and to the point. 0.15. What is the ratio of the Aid flow (current US$) of Sub-Saharan Africa (all income levels) in 2005 to that in 2010?
Make the answer very short. 0.27. What is the ratio of the Aid flow (current US$) in Djibouti in 2005 to that in 2010?
Offer a terse response. 0.37. What is the ratio of the Aid flow (current US$) in Sub-Saharan Africa (all income levels) in 2005 to that in 2011?
Provide a short and direct response. 0.21. What is the ratio of the Aid flow (current US$) in Djibouti in 2005 to that in 2011?
Provide a succinct answer. 0.26. What is the ratio of the Aid flow (current US$) in Libya in 2005 to that in 2011?
Your answer should be compact. 0.03. What is the ratio of the Aid flow (current US$) in Sub-Saharan Africa (all income levels) in 2005 to that in 2012?
Your response must be concise. 0.14. What is the ratio of the Aid flow (current US$) in Djibouti in 2005 to that in 2012?
Ensure brevity in your answer.  0.09. What is the ratio of the Aid flow (current US$) in Libya in 2005 to that in 2012?
Provide a succinct answer. 0.07. What is the ratio of the Aid flow (current US$) of Sub-Saharan Africa (all income levels) in 2006 to that in 2007?
Give a very brief answer. 0.66. What is the ratio of the Aid flow (current US$) in Djibouti in 2006 to that in 2007?
Provide a short and direct response. 0.93. What is the ratio of the Aid flow (current US$) in Libya in 2006 to that in 2007?
Your answer should be very brief. 0.14. What is the ratio of the Aid flow (current US$) of Sub-Saharan Africa (all income levels) in 2006 to that in 2008?
Offer a terse response. 0.44. What is the ratio of the Aid flow (current US$) of Djibouti in 2006 to that in 2008?
Make the answer very short. 2.12. What is the ratio of the Aid flow (current US$) of Libya in 2006 to that in 2008?
Ensure brevity in your answer.  0.12. What is the ratio of the Aid flow (current US$) of Sub-Saharan Africa (all income levels) in 2006 to that in 2010?
Give a very brief answer. 0.31. What is the ratio of the Aid flow (current US$) of Djibouti in 2006 to that in 2010?
Your answer should be very brief. 1.96. What is the ratio of the Aid flow (current US$) in Libya in 2006 to that in 2010?
Give a very brief answer. 0.25. What is the ratio of the Aid flow (current US$) of Sub-Saharan Africa (all income levels) in 2006 to that in 2011?
Your answer should be very brief. 0.24. What is the ratio of the Aid flow (current US$) in Djibouti in 2006 to that in 2011?
Your answer should be compact. 1.36. What is the ratio of the Aid flow (current US$) in Libya in 2006 to that in 2011?
Keep it short and to the point. 0.03. What is the ratio of the Aid flow (current US$) in Sub-Saharan Africa (all income levels) in 2006 to that in 2012?
Give a very brief answer. 0.16. What is the ratio of the Aid flow (current US$) of Djibouti in 2006 to that in 2012?
Your answer should be compact. 0.46. What is the ratio of the Aid flow (current US$) in Libya in 2006 to that in 2012?
Offer a terse response. 0.05. What is the ratio of the Aid flow (current US$) of Sub-Saharan Africa (all income levels) in 2007 to that in 2008?
Your answer should be very brief. 0.66. What is the ratio of the Aid flow (current US$) in Djibouti in 2007 to that in 2008?
Offer a very short reply. 2.28. What is the ratio of the Aid flow (current US$) in Libya in 2007 to that in 2008?
Offer a very short reply. 0.81. What is the ratio of the Aid flow (current US$) in Sub-Saharan Africa (all income levels) in 2007 to that in 2010?
Offer a terse response. 0.47. What is the ratio of the Aid flow (current US$) of Djibouti in 2007 to that in 2010?
Your response must be concise. 2.11. What is the ratio of the Aid flow (current US$) of Libya in 2007 to that in 2010?
Ensure brevity in your answer.  1.75. What is the ratio of the Aid flow (current US$) in Papua New Guinea in 2007 to that in 2010?
Provide a short and direct response. 1.77. What is the ratio of the Aid flow (current US$) of Sub-Saharan Africa (all income levels) in 2007 to that in 2011?
Your answer should be very brief. 0.37. What is the ratio of the Aid flow (current US$) of Djibouti in 2007 to that in 2011?
Give a very brief answer. 1.46. What is the ratio of the Aid flow (current US$) of Libya in 2007 to that in 2011?
Provide a short and direct response. 0.18. What is the ratio of the Aid flow (current US$) of Papua New Guinea in 2007 to that in 2011?
Your response must be concise. 1.01. What is the ratio of the Aid flow (current US$) in Sub-Saharan Africa (all income levels) in 2007 to that in 2012?
Keep it short and to the point. 0.24. What is the ratio of the Aid flow (current US$) of Djibouti in 2007 to that in 2012?
Provide a succinct answer. 0.49. What is the ratio of the Aid flow (current US$) of Libya in 2007 to that in 2012?
Your answer should be very brief. 0.35. What is the ratio of the Aid flow (current US$) in Papua New Guinea in 2007 to that in 2012?
Give a very brief answer. 34.5. What is the ratio of the Aid flow (current US$) in Sub-Saharan Africa (all income levels) in 2008 to that in 2010?
Provide a succinct answer. 0.7. What is the ratio of the Aid flow (current US$) of Djibouti in 2008 to that in 2010?
Keep it short and to the point. 0.93. What is the ratio of the Aid flow (current US$) in Libya in 2008 to that in 2010?
Provide a succinct answer. 2.17. What is the ratio of the Aid flow (current US$) in Sub-Saharan Africa (all income levels) in 2008 to that in 2011?
Provide a succinct answer. 0.55. What is the ratio of the Aid flow (current US$) of Djibouti in 2008 to that in 2011?
Give a very brief answer. 0.64. What is the ratio of the Aid flow (current US$) in Libya in 2008 to that in 2011?
Give a very brief answer. 0.23. What is the ratio of the Aid flow (current US$) in Sub-Saharan Africa (all income levels) in 2008 to that in 2012?
Make the answer very short. 0.36. What is the ratio of the Aid flow (current US$) of Djibouti in 2008 to that in 2012?
Provide a short and direct response. 0.22. What is the ratio of the Aid flow (current US$) in Libya in 2008 to that in 2012?
Ensure brevity in your answer.  0.44. What is the ratio of the Aid flow (current US$) of Sub-Saharan Africa (all income levels) in 2010 to that in 2011?
Give a very brief answer. 0.79. What is the ratio of the Aid flow (current US$) in Djibouti in 2010 to that in 2011?
Provide a short and direct response. 0.69. What is the ratio of the Aid flow (current US$) in Libya in 2010 to that in 2011?
Provide a succinct answer. 0.1. What is the ratio of the Aid flow (current US$) of Papua New Guinea in 2010 to that in 2011?
Provide a succinct answer. 0.57. What is the ratio of the Aid flow (current US$) of Sub-Saharan Africa (all income levels) in 2010 to that in 2012?
Offer a terse response. 0.51. What is the ratio of the Aid flow (current US$) in Djibouti in 2010 to that in 2012?
Your answer should be very brief. 0.23. What is the ratio of the Aid flow (current US$) in Libya in 2010 to that in 2012?
Give a very brief answer. 0.2. What is the ratio of the Aid flow (current US$) of Sub-Saharan Africa (all income levels) in 2011 to that in 2012?
Give a very brief answer. 0.65. What is the ratio of the Aid flow (current US$) of Djibouti in 2011 to that in 2012?
Ensure brevity in your answer.  0.34. What is the ratio of the Aid flow (current US$) of Libya in 2011 to that in 2012?
Your answer should be compact. 1.93. What is the difference between the highest and the second highest Aid flow (current US$) in Sub-Saharan Africa (all income levels)?
Provide a short and direct response. 8.37e+07. What is the difference between the highest and the second highest Aid flow (current US$) of Djibouti?
Keep it short and to the point. 5.90e+05. What is the difference between the highest and the second highest Aid flow (current US$) in Libya?
Offer a terse response. 1.11e+06. What is the difference between the highest and the lowest Aid flow (current US$) of Sub-Saharan Africa (all income levels)?
Offer a very short reply. 2.20e+08. What is the difference between the highest and the lowest Aid flow (current US$) of Djibouti?
Your response must be concise. 1.07e+06. What is the difference between the highest and the lowest Aid flow (current US$) of Libya?
Ensure brevity in your answer.  2.24e+06. What is the difference between the highest and the lowest Aid flow (current US$) in Papua New Guinea?
Offer a terse response. 6.90e+05. 